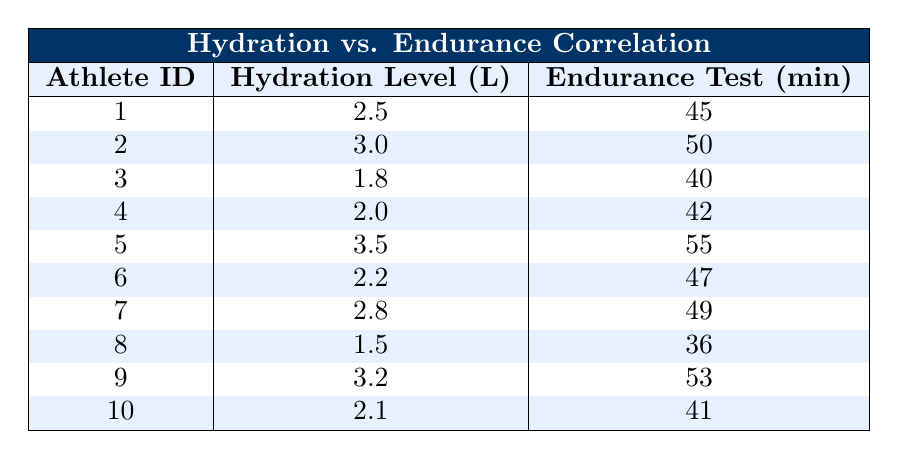What is the hydration level of Athlete ID 5? Referring to the table, Athlete ID 5 has a hydration level of 3.5 liters, which is clearly stated in the corresponding row.
Answer: 3.5 What endurance test result corresponds to Athlete ID 8? Looking at the table, Athlete ID 8's endurance test result is 36 minutes, which is provided next to the athlete's hydration level in the table.
Answer: 36 What is the average endurance test result for all the athletes? To find the average, we sum all the endurance test results: (45 + 50 + 40 + 42 + 55 + 47 + 49 + 36 + 53 + 41) = 408. There are 10 athletes, so we divide 408 by 10, yielding an average of 40.8.
Answer: 40.8 Is there any athlete with a hydration level less than 2.0 liters? By checking the table, we see Athlete ID 3 with a hydration level of 1.8 liters. Thus, there is at least one athlete with a hydration level below 2.0 liters.
Answer: Yes Which athlete has the highest endurance test result, and what is it? Upon reviewing the endurance test results in the table, Athlete ID 5 has the highest score at 55 minutes, which we can find in the row corresponding to this athlete.
Answer: Athlete ID 5, 55 minutes What is the difference in endurance test times between Athlete ID 1 and Athlete ID 9? Athlete ID 1 has an endurance test result of 45 minutes, while Athlete ID 9 has 53 minutes. The difference is calculated as 53 - 45 = 8 minutes.
Answer: 8 How many athletes had a hydration level greater than or equal to 2.5 liters? Counting from the table, the athletes with hydration levels of 2.5 liters or more are Athlete ID 1, 2, 5, 7, and 9, which totals 5 athletes.
Answer: 5 What is the relationship between hydration levels and endurance test results? Is it positive, negative, or neutral? Reviewing the data, higher hydration levels tend to correlate with better endurance test results, suggesting a positive relationship as seen from the increasing endurance times alongside increasing hydration levels.
Answer: Positive 